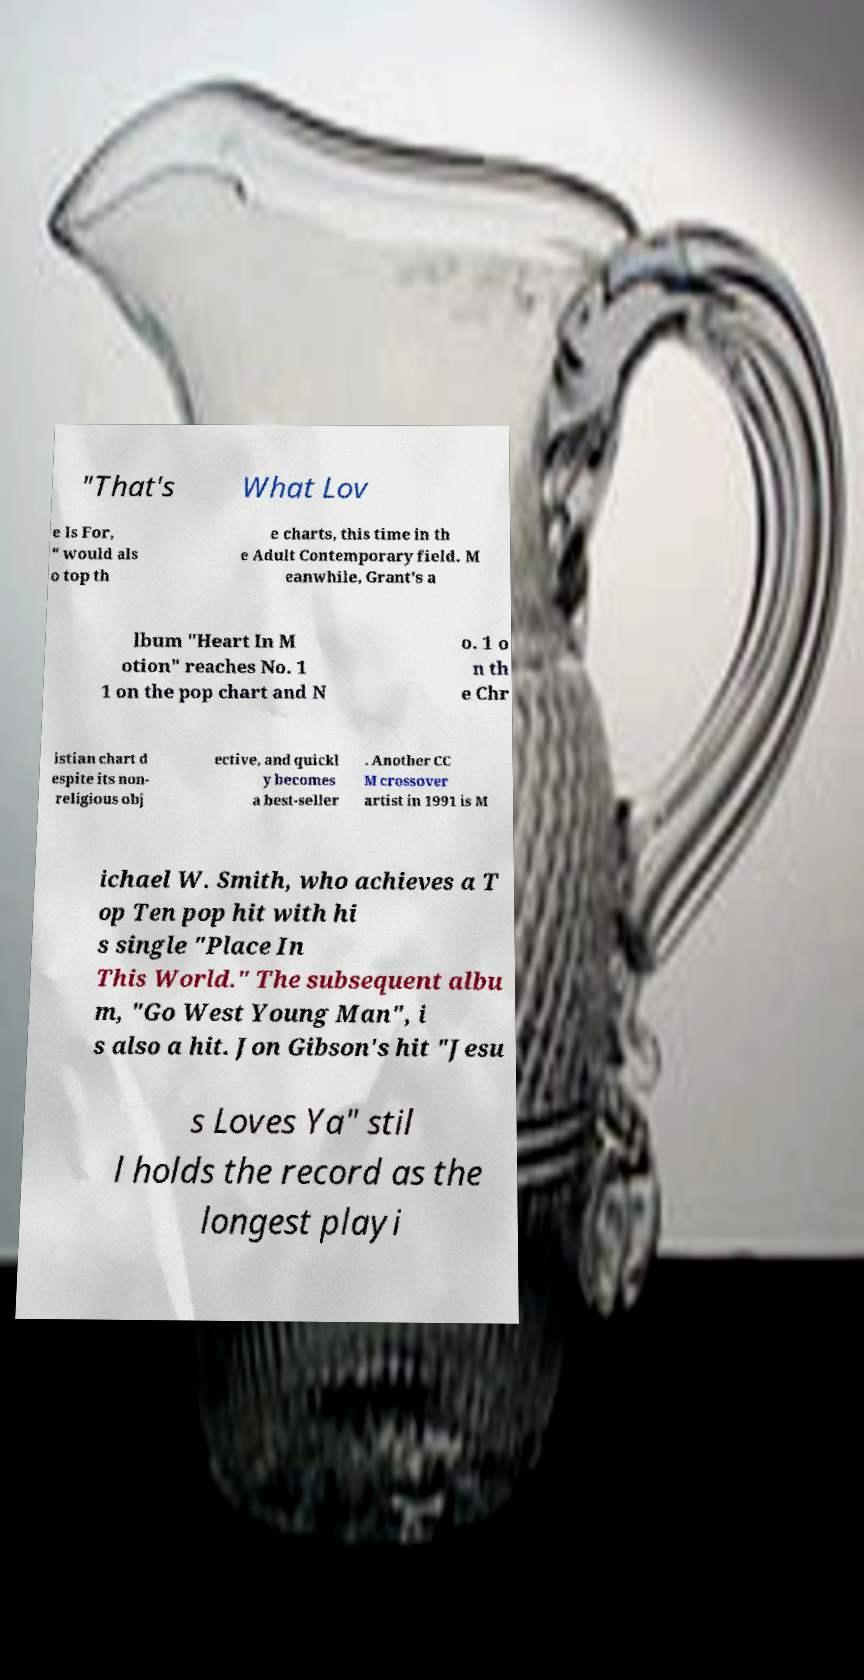For documentation purposes, I need the text within this image transcribed. Could you provide that? "That's What Lov e Is For, " would als o top th e charts, this time in th e Adult Contemporary field. M eanwhile, Grant's a lbum "Heart In M otion" reaches No. 1 1 on the pop chart and N o. 1 o n th e Chr istian chart d espite its non- religious obj ective, and quickl y becomes a best-seller . Another CC M crossover artist in 1991 is M ichael W. Smith, who achieves a T op Ten pop hit with hi s single "Place In This World." The subsequent albu m, "Go West Young Man", i s also a hit. Jon Gibson's hit "Jesu s Loves Ya" stil l holds the record as the longest playi 